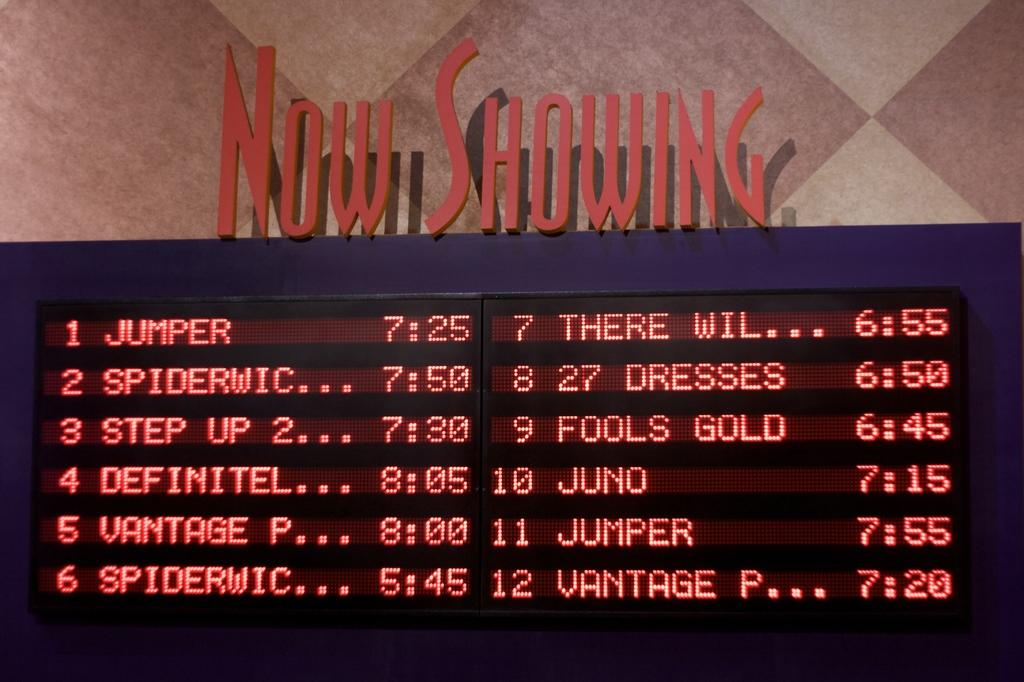What can be seen on the display board in the image? There is a display board with show timings in the image. Where is the display board located in relation to the viewer? The display board is in front. What is visible at the bottom of the image? There is a floor visible at the bottom of the image. Reasoning: Let'g: Let's think step by step in order to produce the conversation. We start by identifying the main subject in the image, which is the display board with show timings. Then, we describe the location of the display board in relation to the viewer. Finally, we mention the floor visible at the bottom of the image. Each question is designed to elicit a specific detail about the image that is known from the provided facts. Absurd Question/Answer: What type of butter is being used to grease the camera in the image? There is no butter or camera present in the image. 